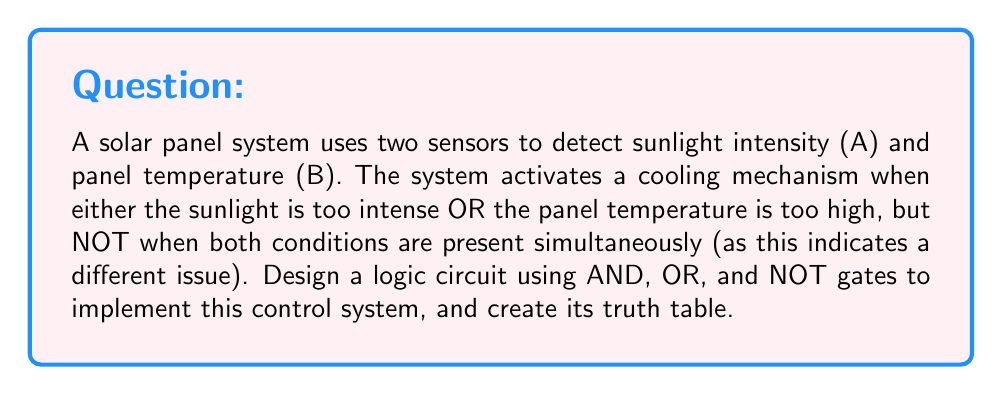Show me your answer to this math problem. Let's approach this step-by-step:

1) First, we need to define our logic equation. The system activates when:
   (A OR B) AND NOT(A AND B)

2) We can represent this using logic gates:
   $$(A + B) \cdot \overline{(A \cdot B)}$$

3) Now, let's create the truth table:

   | A | B | A + B | A · B | $\overline{(A \cdot B)}$ | $(A + B) \cdot \overline{(A \cdot B)}$ |
   |---|---|-------|-------|-------------------------|---------------------------------------|
   | 0 | 0 |   0   |   0   |           1             |                 0                     |
   | 0 | 1 |   1   |   0   |           1             |                 1                     |
   | 1 | 0 |   1   |   0   |           1             |                 1                     |
   | 1 | 1 |   1   |   1   |           0             |                 0                     |

4) To create this logic circuit:
   - Use an OR gate for (A + B)
   - Use an AND gate for (A · B)
   - Use a NOT gate for $\overline{(A \cdot B)}$
   - Use a final AND gate to combine $(A + B)$ and $\overline{(A \cdot B)}$

5) The resulting circuit can be represented as:

   [asy]
   import geometry;

   // Define points
   pair A = (0,0), B = (0,-40), OR = (80,-20), AND1 = (80,-60), NOT = (160,-60), AND2 = (240,-40);

   // Draw gates
   draw((-20,-20)--(20,-20)--(40,0)--(-20,-20), p=fontsize(10pt));
   draw((60,-60)--(100,-60)--(100,-40)--(60,-60), p=fontsize(10pt));
   draw(circle((160,-60),20), p=fontsize(10pt));
   draw((220,-40)--(260,-40)--(260,-20)--(220,-40), p=fontsize(10pt));

   // Draw connections
   draw(A--(-20,-20));
   draw(B--(-20,-20));
   draw((40,0)--(60,0)--(60,-20)--(220,-20));
   draw(A--(0,-60)--(60,-60));
   draw(B--(0,-80)--(60,-80));
   draw((100,-60)--(140,-60));
   draw((180,-60)--(220,-60));

   // Labels
   label("A", A, W);
   label("B", B, W);
   label("OR", (0,-20), W);
   label("AND", (80,-60), S);
   label("NOT", (160,-60), S);
   label("AND", (240,-40), E);
   label("Output", (280,-40), E);
   [/asy]

This circuit will activate the cooling mechanism when either A or B is high (1), but not when both are high simultaneously, as per the requirements of the solar panel system.
Answer: Truth table: 0011 